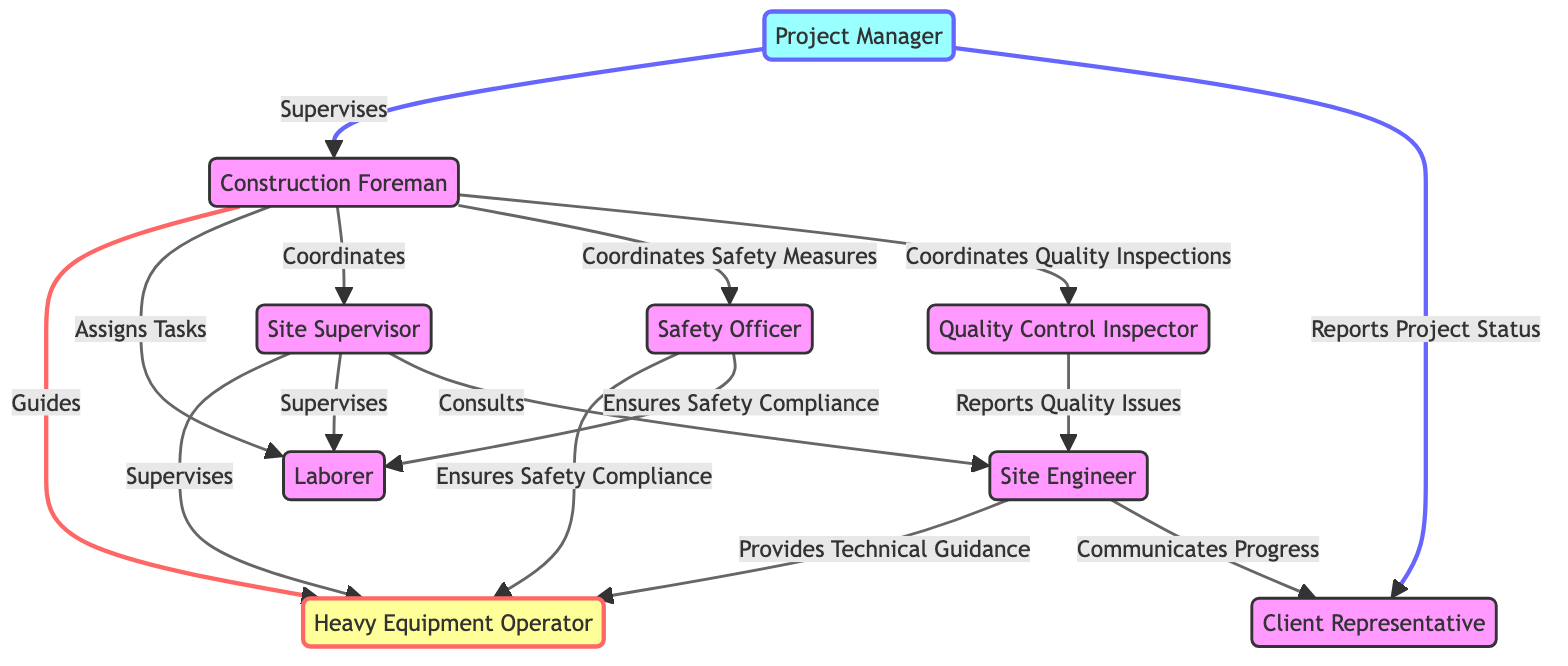What is the total number of nodes in the diagram? The nodes represent distinct roles in the communication channel hierarchy. Counting each unique role listed in the nodes section gives us a total of 9 roles.
Answer: 9 Who guides the Heavy Equipment Operator? The relationship between nodes can be traced with the "Guides" label linked from the Foreman to the Operator. This indicates that the Construction Foreman guides the Heavy Equipment Operator.
Answer: Construction Foreman How many edges connect to the Supervisor? To find the number of edges connected to the Supervisor, we can go through the edges list and count the instances where "Supervisor" appears as a target node. There are 4 edges connected to the Supervisor.
Answer: 4 What type of relationship exists between the Engineer and the Operator? The relationship is described as "Provides Technical Guidance," which indicates the Engineer's role in guiding the Operator. This can be found in the edges section, connecting Engineer to Operator.
Answer: Provides Technical Guidance Which role communicates the project status to the Client Representative? Following the directed edge from the Project Manager to the Client Representative with the label "Reports Project Status" indicates that the Project Manager handles this communication.
Answer: Project Manager Which roles does the Foreman coordinate with? The diagram indicates several connections from the Foreman: to the Supervisor, Safety Officer, and Quality Control Inspector labeled as "Coordinates." This shows the Foreman's duty to coordinate these roles.
Answer: Supervisor, Safety Officer, Quality Control Inspector How many unique roles are responsible for ensuring safety compliance? Both the Safety Officer to the Operator and the Safety Officer to the Laborer have edges labeled "Ensures Safety Compliance," making a total of 2 unique roles responsible for this aspect.
Answer: 2 What is the relationship that exists between the Supervisor and the Engineer? The diagram shows a directed edge from Supervisor to Engineer labeled "Consults," meaning that the Supervisor has a consulting relationship with the Engineer.
Answer: Consults Which role reports quality issues and to whom? The Quality Control Inspector reports quality issues to the Engineer as indicated by the edge labeled "Reports Quality Issues." Thus, the relationship can be described from QC to Engineer.
Answer: Engineer 